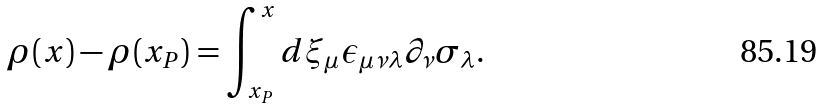<formula> <loc_0><loc_0><loc_500><loc_500>\rho ( x ) - \rho ( x _ { P } ) = \int _ { x _ { P } } ^ { x } d \xi _ { \mu } \epsilon _ { \mu \nu \lambda } \partial _ { \nu } \sigma _ { \lambda } .</formula> 